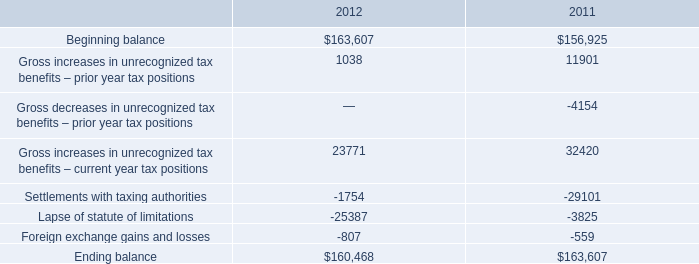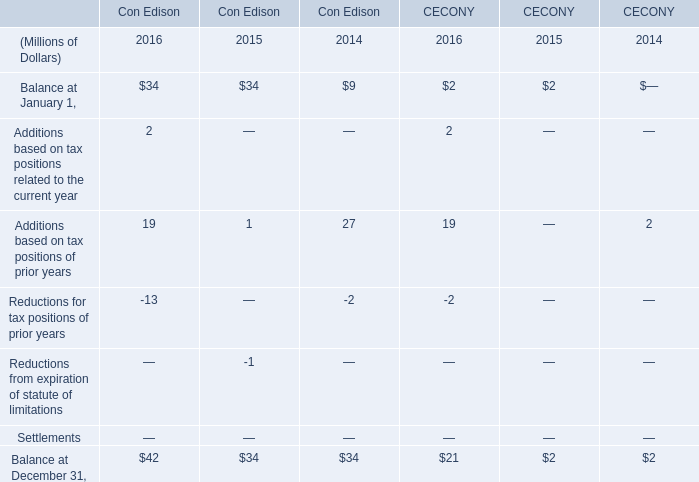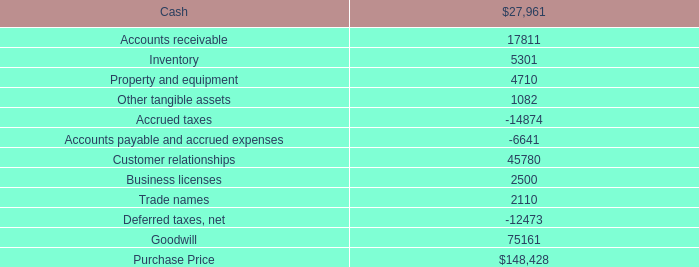what's the total amount of Accounts payable and accrued expenses, and Settlements with taxing authorities of 2011 ? 
Computations: (6641.0 + 29101.0)
Answer: 35742.0. 